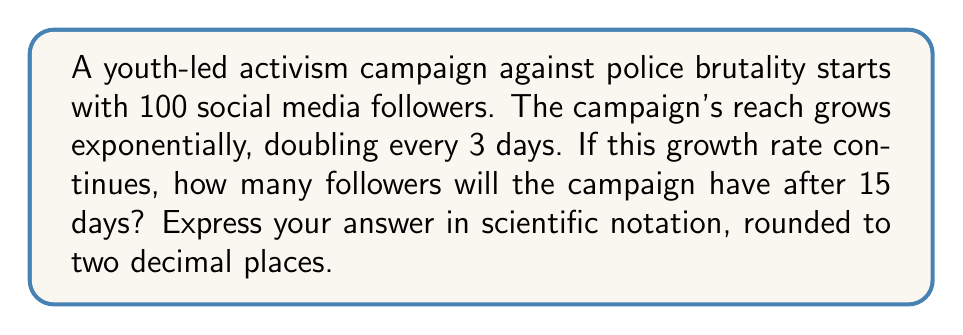What is the answer to this math problem? Let's approach this step-by-step:

1) We can model this growth using the exponential function:

   $$ A(t) = A_0 \cdot b^{t/d} $$

   Where:
   $A(t)$ is the number of followers after time $t$
   $A_0$ is the initial number of followers
   $b$ is the growth factor
   $d$ is the time it takes for the followers to increase by a factor of $b$

2) In this case:
   $A_0 = 100$ (initial followers)
   $b = 2$ (doubling each period)
   $d = 3$ days (time to double)
   $t = 15$ days (time we're calculating for)

3) Plugging these values into our equation:

   $$ A(15) = 100 \cdot 2^{15/3} $$

4) Simplify the exponent:

   $$ A(15) = 100 \cdot 2^5 $$

5) Calculate $2^5$:

   $$ A(15) = 100 \cdot 32 = 3200 $$

6) Convert to scientific notation and round to two decimal places:

   $$ A(15) \approx 3.20 \times 10^3 $$
Answer: $3.20 \times 10^3$ 